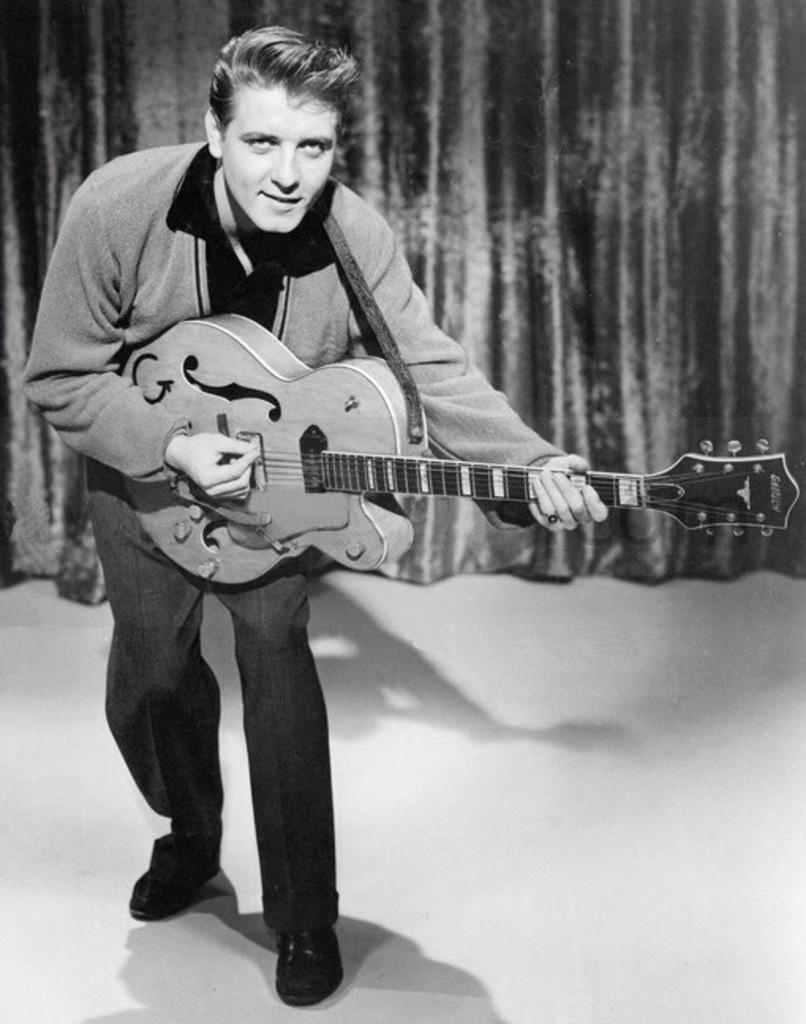What is the person in the image doing? The person is playing a guitar. What object is present in the image that might be used for covering or dividing a space? There is a curtain in the image. How many tomatoes are on the person's head in the image? There are no tomatoes present in the image. What type of legal advice is the person in the image providing? The person in the image is not depicted as a lawyer or providing legal advice. 